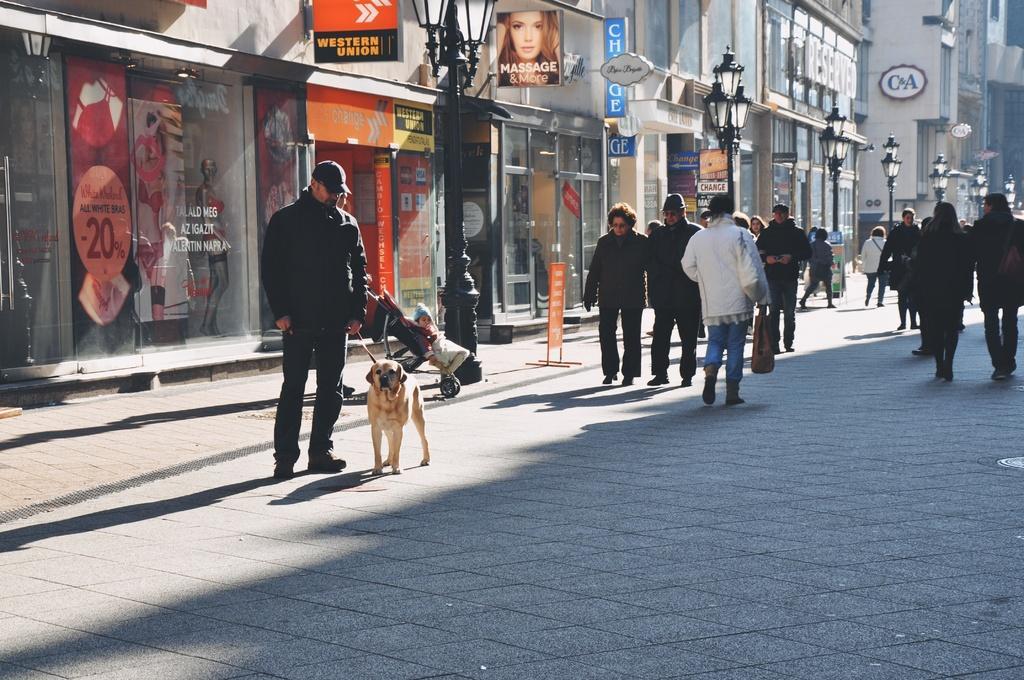Can you describe this image briefly? In this image I can see this a group of people who are walking on the road and the person on the left side is wearing a black hat and holding a dog on the street. Behind this man I can see there are buildings, street lights and board. 